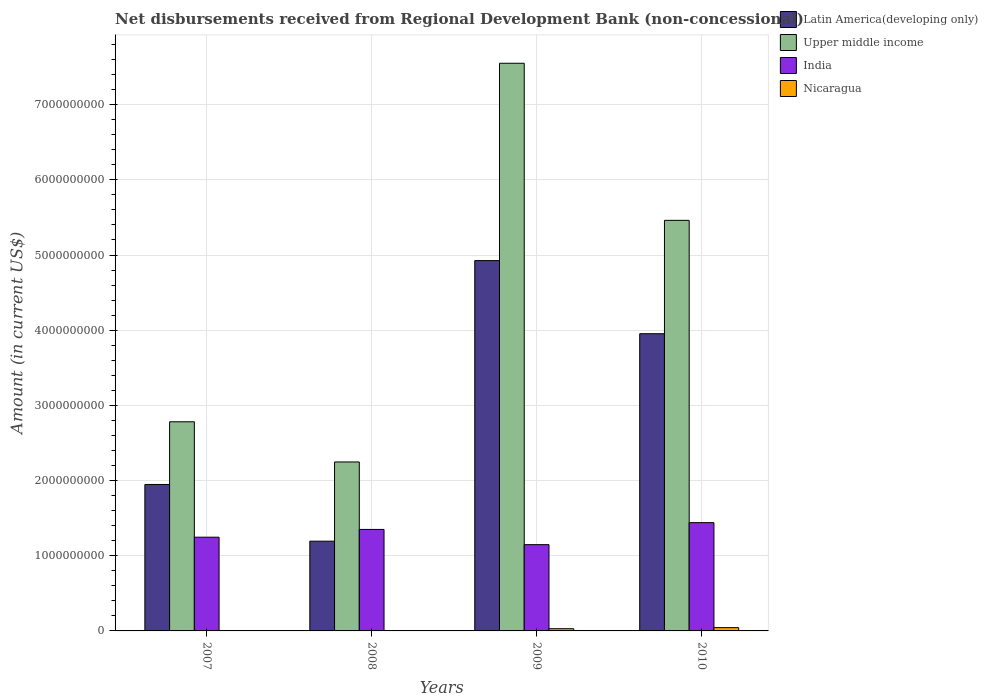How many different coloured bars are there?
Give a very brief answer. 4. How many groups of bars are there?
Your response must be concise. 4. Are the number of bars per tick equal to the number of legend labels?
Your response must be concise. No. Are the number of bars on each tick of the X-axis equal?
Make the answer very short. No. How many bars are there on the 4th tick from the left?
Offer a terse response. 4. How many bars are there on the 3rd tick from the right?
Offer a terse response. 3. What is the amount of disbursements received from Regional Development Bank in Upper middle income in 2007?
Give a very brief answer. 2.78e+09. Across all years, what is the maximum amount of disbursements received from Regional Development Bank in Nicaragua?
Your answer should be compact. 4.37e+07. In which year was the amount of disbursements received from Regional Development Bank in Nicaragua maximum?
Offer a terse response. 2010. What is the total amount of disbursements received from Regional Development Bank in Latin America(developing only) in the graph?
Ensure brevity in your answer.  1.20e+1. What is the difference between the amount of disbursements received from Regional Development Bank in Upper middle income in 2007 and that in 2009?
Your answer should be very brief. -4.77e+09. What is the difference between the amount of disbursements received from Regional Development Bank in Upper middle income in 2008 and the amount of disbursements received from Regional Development Bank in Nicaragua in 2009?
Make the answer very short. 2.22e+09. What is the average amount of disbursements received from Regional Development Bank in Nicaragua per year?
Keep it short and to the point. 1.83e+07. In the year 2007, what is the difference between the amount of disbursements received from Regional Development Bank in Upper middle income and amount of disbursements received from Regional Development Bank in Latin America(developing only)?
Ensure brevity in your answer.  8.34e+08. What is the ratio of the amount of disbursements received from Regional Development Bank in Nicaragua in 2009 to that in 2010?
Keep it short and to the point. 0.67. Is the amount of disbursements received from Regional Development Bank in Latin America(developing only) in 2008 less than that in 2009?
Give a very brief answer. Yes. What is the difference between the highest and the second highest amount of disbursements received from Regional Development Bank in India?
Your answer should be compact. 9.03e+07. What is the difference between the highest and the lowest amount of disbursements received from Regional Development Bank in Nicaragua?
Offer a very short reply. 4.37e+07. Is the sum of the amount of disbursements received from Regional Development Bank in Upper middle income in 2008 and 2010 greater than the maximum amount of disbursements received from Regional Development Bank in Latin America(developing only) across all years?
Provide a short and direct response. Yes. Is it the case that in every year, the sum of the amount of disbursements received from Regional Development Bank in Upper middle income and amount of disbursements received from Regional Development Bank in Latin America(developing only) is greater than the sum of amount of disbursements received from Regional Development Bank in India and amount of disbursements received from Regional Development Bank in Nicaragua?
Ensure brevity in your answer.  No. How many bars are there?
Your response must be concise. 14. Are all the bars in the graph horizontal?
Ensure brevity in your answer.  No. Does the graph contain any zero values?
Your answer should be compact. Yes. How many legend labels are there?
Ensure brevity in your answer.  4. What is the title of the graph?
Ensure brevity in your answer.  Net disbursements received from Regional Development Bank (non-concessional). What is the label or title of the X-axis?
Offer a very short reply. Years. What is the label or title of the Y-axis?
Your answer should be compact. Amount (in current US$). What is the Amount (in current US$) of Latin America(developing only) in 2007?
Make the answer very short. 1.95e+09. What is the Amount (in current US$) of Upper middle income in 2007?
Ensure brevity in your answer.  2.78e+09. What is the Amount (in current US$) in India in 2007?
Keep it short and to the point. 1.25e+09. What is the Amount (in current US$) of Nicaragua in 2007?
Offer a terse response. 0. What is the Amount (in current US$) in Latin America(developing only) in 2008?
Offer a terse response. 1.19e+09. What is the Amount (in current US$) of Upper middle income in 2008?
Offer a very short reply. 2.25e+09. What is the Amount (in current US$) in India in 2008?
Your answer should be very brief. 1.35e+09. What is the Amount (in current US$) in Latin America(developing only) in 2009?
Keep it short and to the point. 4.93e+09. What is the Amount (in current US$) in Upper middle income in 2009?
Make the answer very short. 7.55e+09. What is the Amount (in current US$) in India in 2009?
Make the answer very short. 1.15e+09. What is the Amount (in current US$) in Nicaragua in 2009?
Your answer should be compact. 2.95e+07. What is the Amount (in current US$) of Latin America(developing only) in 2010?
Your response must be concise. 3.95e+09. What is the Amount (in current US$) of Upper middle income in 2010?
Keep it short and to the point. 5.46e+09. What is the Amount (in current US$) in India in 2010?
Your answer should be very brief. 1.44e+09. What is the Amount (in current US$) of Nicaragua in 2010?
Your answer should be compact. 4.37e+07. Across all years, what is the maximum Amount (in current US$) in Latin America(developing only)?
Your response must be concise. 4.93e+09. Across all years, what is the maximum Amount (in current US$) of Upper middle income?
Keep it short and to the point. 7.55e+09. Across all years, what is the maximum Amount (in current US$) of India?
Make the answer very short. 1.44e+09. Across all years, what is the maximum Amount (in current US$) of Nicaragua?
Offer a very short reply. 4.37e+07. Across all years, what is the minimum Amount (in current US$) in Latin America(developing only)?
Provide a short and direct response. 1.19e+09. Across all years, what is the minimum Amount (in current US$) in Upper middle income?
Offer a very short reply. 2.25e+09. Across all years, what is the minimum Amount (in current US$) of India?
Your answer should be compact. 1.15e+09. Across all years, what is the minimum Amount (in current US$) of Nicaragua?
Offer a terse response. 0. What is the total Amount (in current US$) in Latin America(developing only) in the graph?
Provide a succinct answer. 1.20e+1. What is the total Amount (in current US$) in Upper middle income in the graph?
Make the answer very short. 1.80e+1. What is the total Amount (in current US$) in India in the graph?
Your answer should be very brief. 5.18e+09. What is the total Amount (in current US$) in Nicaragua in the graph?
Provide a succinct answer. 7.32e+07. What is the difference between the Amount (in current US$) of Latin America(developing only) in 2007 and that in 2008?
Keep it short and to the point. 7.54e+08. What is the difference between the Amount (in current US$) in Upper middle income in 2007 and that in 2008?
Provide a short and direct response. 5.35e+08. What is the difference between the Amount (in current US$) in India in 2007 and that in 2008?
Keep it short and to the point. -1.03e+08. What is the difference between the Amount (in current US$) in Latin America(developing only) in 2007 and that in 2009?
Keep it short and to the point. -2.98e+09. What is the difference between the Amount (in current US$) of Upper middle income in 2007 and that in 2009?
Provide a short and direct response. -4.77e+09. What is the difference between the Amount (in current US$) of India in 2007 and that in 2009?
Your answer should be very brief. 9.92e+07. What is the difference between the Amount (in current US$) in Latin America(developing only) in 2007 and that in 2010?
Offer a terse response. -2.01e+09. What is the difference between the Amount (in current US$) of Upper middle income in 2007 and that in 2010?
Keep it short and to the point. -2.68e+09. What is the difference between the Amount (in current US$) of India in 2007 and that in 2010?
Provide a succinct answer. -1.93e+08. What is the difference between the Amount (in current US$) in Latin America(developing only) in 2008 and that in 2009?
Make the answer very short. -3.73e+09. What is the difference between the Amount (in current US$) in Upper middle income in 2008 and that in 2009?
Your answer should be very brief. -5.30e+09. What is the difference between the Amount (in current US$) in India in 2008 and that in 2009?
Keep it short and to the point. 2.02e+08. What is the difference between the Amount (in current US$) in Latin America(developing only) in 2008 and that in 2010?
Provide a succinct answer. -2.76e+09. What is the difference between the Amount (in current US$) of Upper middle income in 2008 and that in 2010?
Offer a very short reply. -3.21e+09. What is the difference between the Amount (in current US$) in India in 2008 and that in 2010?
Offer a terse response. -9.03e+07. What is the difference between the Amount (in current US$) of Latin America(developing only) in 2009 and that in 2010?
Provide a succinct answer. 9.73e+08. What is the difference between the Amount (in current US$) in Upper middle income in 2009 and that in 2010?
Offer a very short reply. 2.09e+09. What is the difference between the Amount (in current US$) of India in 2009 and that in 2010?
Your answer should be compact. -2.93e+08. What is the difference between the Amount (in current US$) in Nicaragua in 2009 and that in 2010?
Your response must be concise. -1.43e+07. What is the difference between the Amount (in current US$) in Latin America(developing only) in 2007 and the Amount (in current US$) in Upper middle income in 2008?
Keep it short and to the point. -2.99e+08. What is the difference between the Amount (in current US$) of Latin America(developing only) in 2007 and the Amount (in current US$) of India in 2008?
Provide a short and direct response. 5.98e+08. What is the difference between the Amount (in current US$) in Upper middle income in 2007 and the Amount (in current US$) in India in 2008?
Offer a terse response. 1.43e+09. What is the difference between the Amount (in current US$) in Latin America(developing only) in 2007 and the Amount (in current US$) in Upper middle income in 2009?
Ensure brevity in your answer.  -5.60e+09. What is the difference between the Amount (in current US$) of Latin America(developing only) in 2007 and the Amount (in current US$) of India in 2009?
Provide a short and direct response. 8.00e+08. What is the difference between the Amount (in current US$) in Latin America(developing only) in 2007 and the Amount (in current US$) in Nicaragua in 2009?
Your answer should be very brief. 1.92e+09. What is the difference between the Amount (in current US$) in Upper middle income in 2007 and the Amount (in current US$) in India in 2009?
Provide a succinct answer. 1.63e+09. What is the difference between the Amount (in current US$) in Upper middle income in 2007 and the Amount (in current US$) in Nicaragua in 2009?
Provide a succinct answer. 2.75e+09. What is the difference between the Amount (in current US$) in India in 2007 and the Amount (in current US$) in Nicaragua in 2009?
Make the answer very short. 1.22e+09. What is the difference between the Amount (in current US$) in Latin America(developing only) in 2007 and the Amount (in current US$) in Upper middle income in 2010?
Provide a short and direct response. -3.51e+09. What is the difference between the Amount (in current US$) in Latin America(developing only) in 2007 and the Amount (in current US$) in India in 2010?
Your answer should be compact. 5.08e+08. What is the difference between the Amount (in current US$) of Latin America(developing only) in 2007 and the Amount (in current US$) of Nicaragua in 2010?
Offer a very short reply. 1.90e+09. What is the difference between the Amount (in current US$) of Upper middle income in 2007 and the Amount (in current US$) of India in 2010?
Your answer should be very brief. 1.34e+09. What is the difference between the Amount (in current US$) in Upper middle income in 2007 and the Amount (in current US$) in Nicaragua in 2010?
Give a very brief answer. 2.74e+09. What is the difference between the Amount (in current US$) of India in 2007 and the Amount (in current US$) of Nicaragua in 2010?
Offer a terse response. 1.20e+09. What is the difference between the Amount (in current US$) of Latin America(developing only) in 2008 and the Amount (in current US$) of Upper middle income in 2009?
Provide a succinct answer. -6.36e+09. What is the difference between the Amount (in current US$) of Latin America(developing only) in 2008 and the Amount (in current US$) of India in 2009?
Provide a succinct answer. 4.62e+07. What is the difference between the Amount (in current US$) in Latin America(developing only) in 2008 and the Amount (in current US$) in Nicaragua in 2009?
Give a very brief answer. 1.16e+09. What is the difference between the Amount (in current US$) in Upper middle income in 2008 and the Amount (in current US$) in India in 2009?
Ensure brevity in your answer.  1.10e+09. What is the difference between the Amount (in current US$) of Upper middle income in 2008 and the Amount (in current US$) of Nicaragua in 2009?
Make the answer very short. 2.22e+09. What is the difference between the Amount (in current US$) in India in 2008 and the Amount (in current US$) in Nicaragua in 2009?
Provide a short and direct response. 1.32e+09. What is the difference between the Amount (in current US$) of Latin America(developing only) in 2008 and the Amount (in current US$) of Upper middle income in 2010?
Offer a very short reply. -4.27e+09. What is the difference between the Amount (in current US$) in Latin America(developing only) in 2008 and the Amount (in current US$) in India in 2010?
Offer a terse response. -2.46e+08. What is the difference between the Amount (in current US$) in Latin America(developing only) in 2008 and the Amount (in current US$) in Nicaragua in 2010?
Give a very brief answer. 1.15e+09. What is the difference between the Amount (in current US$) of Upper middle income in 2008 and the Amount (in current US$) of India in 2010?
Make the answer very short. 8.07e+08. What is the difference between the Amount (in current US$) in Upper middle income in 2008 and the Amount (in current US$) in Nicaragua in 2010?
Keep it short and to the point. 2.20e+09. What is the difference between the Amount (in current US$) in India in 2008 and the Amount (in current US$) in Nicaragua in 2010?
Provide a succinct answer. 1.31e+09. What is the difference between the Amount (in current US$) of Latin America(developing only) in 2009 and the Amount (in current US$) of Upper middle income in 2010?
Give a very brief answer. -5.35e+08. What is the difference between the Amount (in current US$) in Latin America(developing only) in 2009 and the Amount (in current US$) in India in 2010?
Offer a very short reply. 3.49e+09. What is the difference between the Amount (in current US$) of Latin America(developing only) in 2009 and the Amount (in current US$) of Nicaragua in 2010?
Ensure brevity in your answer.  4.88e+09. What is the difference between the Amount (in current US$) of Upper middle income in 2009 and the Amount (in current US$) of India in 2010?
Offer a terse response. 6.11e+09. What is the difference between the Amount (in current US$) in Upper middle income in 2009 and the Amount (in current US$) in Nicaragua in 2010?
Ensure brevity in your answer.  7.51e+09. What is the difference between the Amount (in current US$) in India in 2009 and the Amount (in current US$) in Nicaragua in 2010?
Your response must be concise. 1.10e+09. What is the average Amount (in current US$) of Latin America(developing only) per year?
Your response must be concise. 3.01e+09. What is the average Amount (in current US$) of Upper middle income per year?
Ensure brevity in your answer.  4.51e+09. What is the average Amount (in current US$) of India per year?
Make the answer very short. 1.30e+09. What is the average Amount (in current US$) of Nicaragua per year?
Provide a short and direct response. 1.83e+07. In the year 2007, what is the difference between the Amount (in current US$) in Latin America(developing only) and Amount (in current US$) in Upper middle income?
Provide a succinct answer. -8.34e+08. In the year 2007, what is the difference between the Amount (in current US$) in Latin America(developing only) and Amount (in current US$) in India?
Your answer should be very brief. 7.01e+08. In the year 2007, what is the difference between the Amount (in current US$) of Upper middle income and Amount (in current US$) of India?
Make the answer very short. 1.54e+09. In the year 2008, what is the difference between the Amount (in current US$) in Latin America(developing only) and Amount (in current US$) in Upper middle income?
Keep it short and to the point. -1.05e+09. In the year 2008, what is the difference between the Amount (in current US$) in Latin America(developing only) and Amount (in current US$) in India?
Ensure brevity in your answer.  -1.56e+08. In the year 2008, what is the difference between the Amount (in current US$) of Upper middle income and Amount (in current US$) of India?
Keep it short and to the point. 8.98e+08. In the year 2009, what is the difference between the Amount (in current US$) of Latin America(developing only) and Amount (in current US$) of Upper middle income?
Provide a succinct answer. -2.62e+09. In the year 2009, what is the difference between the Amount (in current US$) of Latin America(developing only) and Amount (in current US$) of India?
Give a very brief answer. 3.78e+09. In the year 2009, what is the difference between the Amount (in current US$) in Latin America(developing only) and Amount (in current US$) in Nicaragua?
Ensure brevity in your answer.  4.90e+09. In the year 2009, what is the difference between the Amount (in current US$) in Upper middle income and Amount (in current US$) in India?
Make the answer very short. 6.40e+09. In the year 2009, what is the difference between the Amount (in current US$) in Upper middle income and Amount (in current US$) in Nicaragua?
Offer a terse response. 7.52e+09. In the year 2009, what is the difference between the Amount (in current US$) of India and Amount (in current US$) of Nicaragua?
Offer a very short reply. 1.12e+09. In the year 2010, what is the difference between the Amount (in current US$) of Latin America(developing only) and Amount (in current US$) of Upper middle income?
Make the answer very short. -1.51e+09. In the year 2010, what is the difference between the Amount (in current US$) of Latin America(developing only) and Amount (in current US$) of India?
Keep it short and to the point. 2.51e+09. In the year 2010, what is the difference between the Amount (in current US$) of Latin America(developing only) and Amount (in current US$) of Nicaragua?
Your response must be concise. 3.91e+09. In the year 2010, what is the difference between the Amount (in current US$) in Upper middle income and Amount (in current US$) in India?
Keep it short and to the point. 4.02e+09. In the year 2010, what is the difference between the Amount (in current US$) of Upper middle income and Amount (in current US$) of Nicaragua?
Give a very brief answer. 5.42e+09. In the year 2010, what is the difference between the Amount (in current US$) of India and Amount (in current US$) of Nicaragua?
Your answer should be compact. 1.40e+09. What is the ratio of the Amount (in current US$) in Latin America(developing only) in 2007 to that in 2008?
Ensure brevity in your answer.  1.63. What is the ratio of the Amount (in current US$) in Upper middle income in 2007 to that in 2008?
Provide a short and direct response. 1.24. What is the ratio of the Amount (in current US$) in India in 2007 to that in 2008?
Your response must be concise. 0.92. What is the ratio of the Amount (in current US$) of Latin America(developing only) in 2007 to that in 2009?
Offer a terse response. 0.4. What is the ratio of the Amount (in current US$) of Upper middle income in 2007 to that in 2009?
Keep it short and to the point. 0.37. What is the ratio of the Amount (in current US$) of India in 2007 to that in 2009?
Give a very brief answer. 1.09. What is the ratio of the Amount (in current US$) of Latin America(developing only) in 2007 to that in 2010?
Provide a succinct answer. 0.49. What is the ratio of the Amount (in current US$) of Upper middle income in 2007 to that in 2010?
Keep it short and to the point. 0.51. What is the ratio of the Amount (in current US$) in India in 2007 to that in 2010?
Make the answer very short. 0.87. What is the ratio of the Amount (in current US$) in Latin America(developing only) in 2008 to that in 2009?
Ensure brevity in your answer.  0.24. What is the ratio of the Amount (in current US$) of Upper middle income in 2008 to that in 2009?
Your answer should be compact. 0.3. What is the ratio of the Amount (in current US$) of India in 2008 to that in 2009?
Ensure brevity in your answer.  1.18. What is the ratio of the Amount (in current US$) in Latin America(developing only) in 2008 to that in 2010?
Ensure brevity in your answer.  0.3. What is the ratio of the Amount (in current US$) of Upper middle income in 2008 to that in 2010?
Ensure brevity in your answer.  0.41. What is the ratio of the Amount (in current US$) in India in 2008 to that in 2010?
Keep it short and to the point. 0.94. What is the ratio of the Amount (in current US$) of Latin America(developing only) in 2009 to that in 2010?
Make the answer very short. 1.25. What is the ratio of the Amount (in current US$) in Upper middle income in 2009 to that in 2010?
Offer a very short reply. 1.38. What is the ratio of the Amount (in current US$) of India in 2009 to that in 2010?
Ensure brevity in your answer.  0.8. What is the ratio of the Amount (in current US$) in Nicaragua in 2009 to that in 2010?
Your answer should be compact. 0.67. What is the difference between the highest and the second highest Amount (in current US$) of Latin America(developing only)?
Provide a short and direct response. 9.73e+08. What is the difference between the highest and the second highest Amount (in current US$) in Upper middle income?
Make the answer very short. 2.09e+09. What is the difference between the highest and the second highest Amount (in current US$) of India?
Make the answer very short. 9.03e+07. What is the difference between the highest and the lowest Amount (in current US$) in Latin America(developing only)?
Your response must be concise. 3.73e+09. What is the difference between the highest and the lowest Amount (in current US$) in Upper middle income?
Your answer should be compact. 5.30e+09. What is the difference between the highest and the lowest Amount (in current US$) in India?
Provide a succinct answer. 2.93e+08. What is the difference between the highest and the lowest Amount (in current US$) of Nicaragua?
Ensure brevity in your answer.  4.37e+07. 